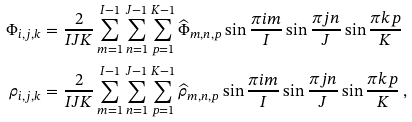Convert formula to latex. <formula><loc_0><loc_0><loc_500><loc_500>\Phi _ { i , j , k } & = \frac { 2 } { I J K } \sum _ { m = 1 } ^ { I - 1 } \sum _ { n = 1 } ^ { J - 1 } \sum _ { p = 1 } ^ { K - 1 } \widehat { \Phi } _ { m , n , p } \sin \frac { \pi i m } { I } \sin \frac { \pi j n } { J } \sin \frac { \pi k p } { K } \\ \rho _ { i , j , k } & = \frac { 2 } { I J K } \sum _ { m = 1 } ^ { I - 1 } \sum _ { n = 1 } ^ { J - 1 } \sum _ { p = 1 } ^ { K - 1 } \widehat { \rho } _ { m , n , p } \sin \frac { \pi i m } { I } \sin \frac { \pi j n } { J } \sin \frac { \pi k p } { K } \, ,</formula> 